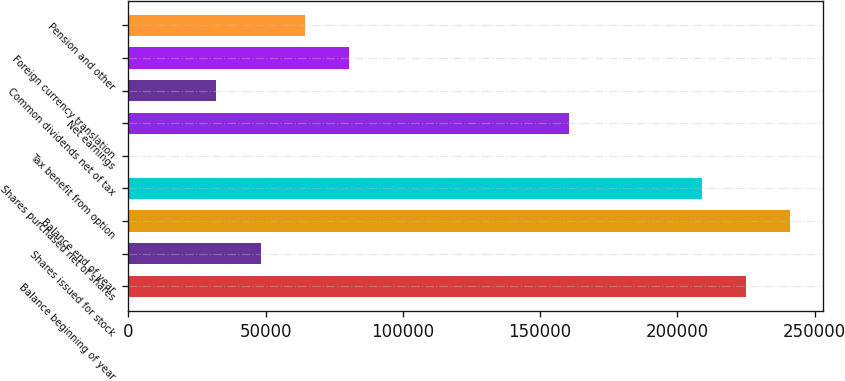Convert chart to OTSL. <chart><loc_0><loc_0><loc_500><loc_500><bar_chart><fcel>Balance beginning of year<fcel>Shares issued for stock<fcel>Balance end of year<fcel>Shares purchased net of shares<fcel>Tax benefit from option<fcel>Net earnings<fcel>Common dividends net of tax<fcel>Foreign currency translation<fcel>Pension and other<nl><fcel>224947<fcel>48210.3<fcel>241014<fcel>208880<fcel>9.5<fcel>160679<fcel>32143.4<fcel>80344.2<fcel>64277.3<nl></chart> 